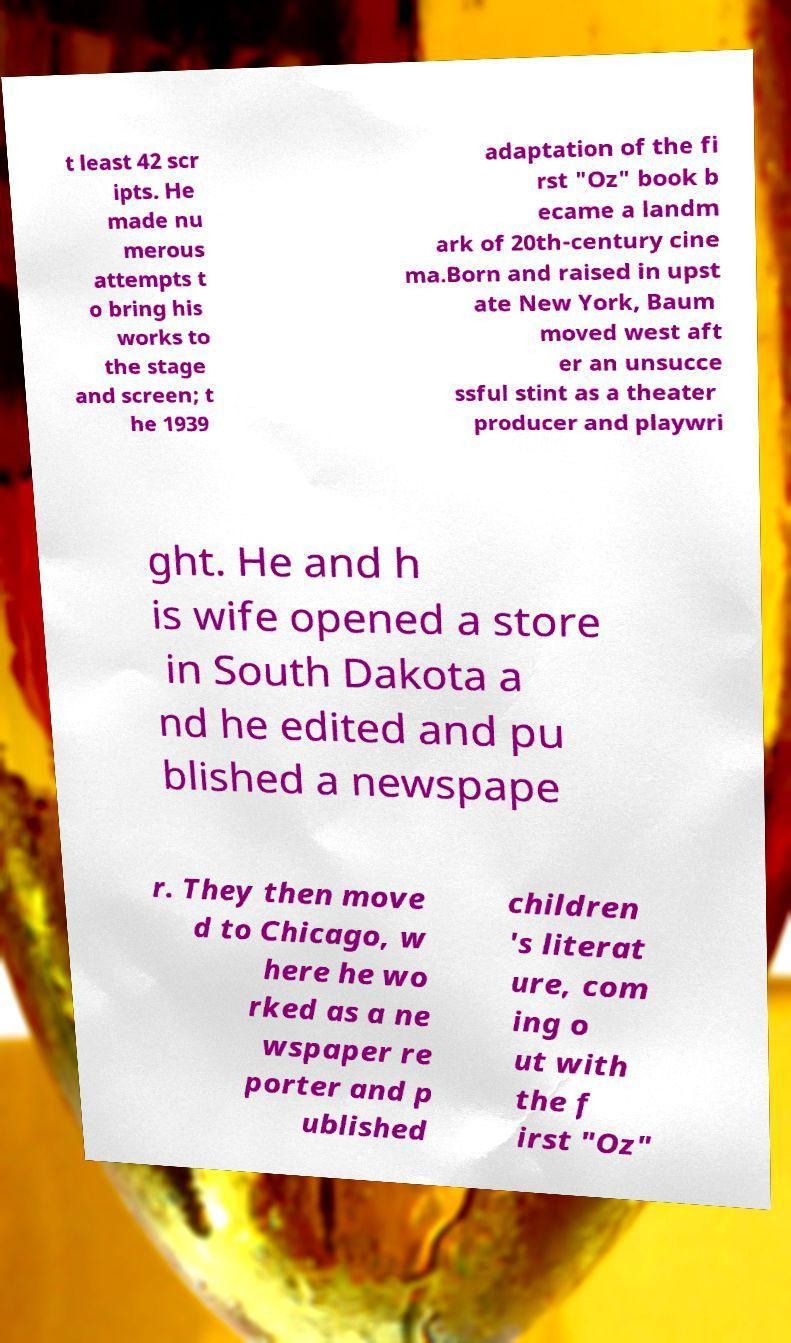Could you assist in decoding the text presented in this image and type it out clearly? t least 42 scr ipts. He made nu merous attempts t o bring his works to the stage and screen; t he 1939 adaptation of the fi rst "Oz" book b ecame a landm ark of 20th-century cine ma.Born and raised in upst ate New York, Baum moved west aft er an unsucce ssful stint as a theater producer and playwri ght. He and h is wife opened a store in South Dakota a nd he edited and pu blished a newspape r. They then move d to Chicago, w here he wo rked as a ne wspaper re porter and p ublished children 's literat ure, com ing o ut with the f irst "Oz" 